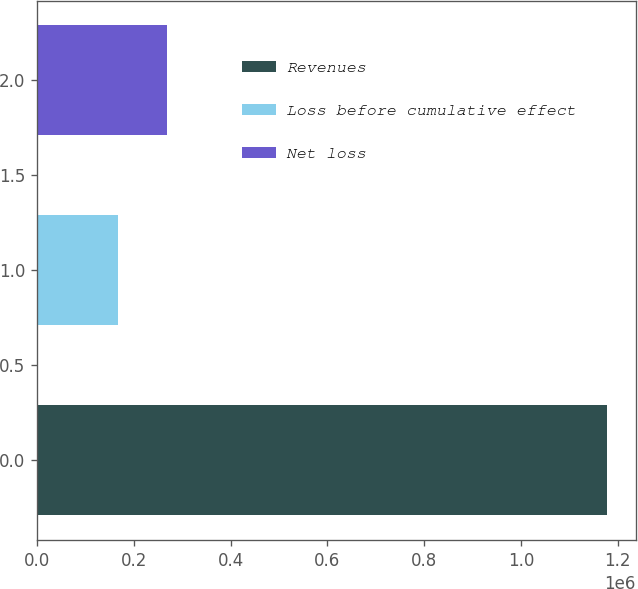Convert chart to OTSL. <chart><loc_0><loc_0><loc_500><loc_500><bar_chart><fcel>Revenues<fcel>Loss before cumulative effect<fcel>Net loss<nl><fcel>1.17828e+06<fcel>168068<fcel>269090<nl></chart> 